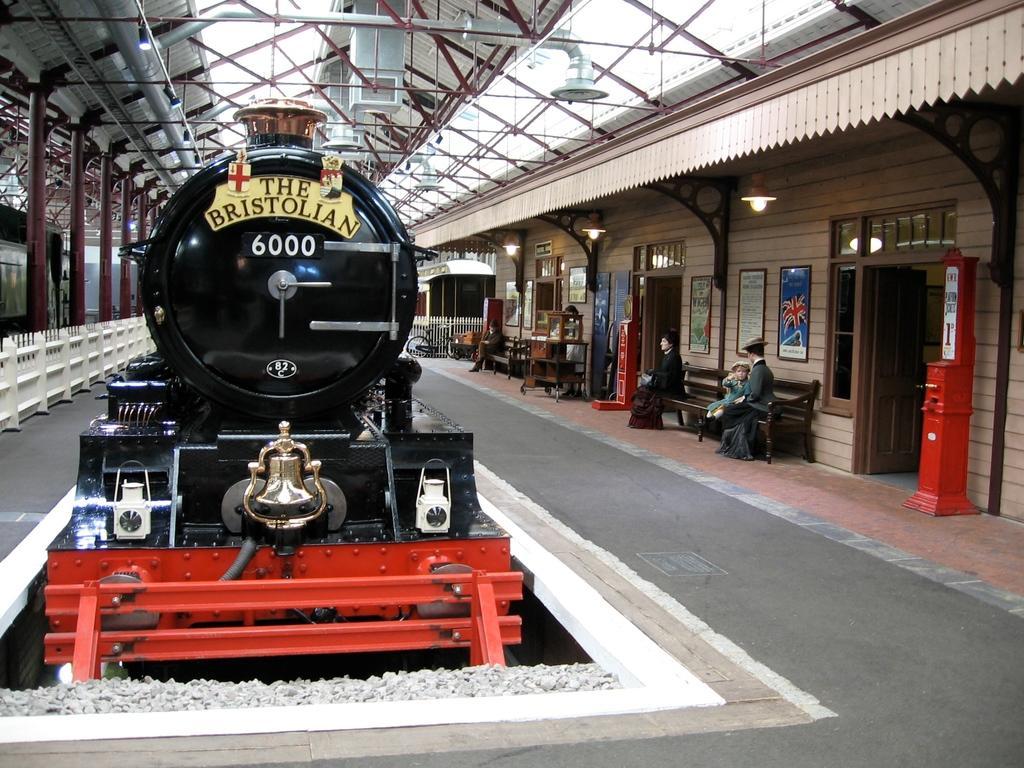How would you summarize this image in a sentence or two? On the left side, there is a black color train on a railway track. Beside this train, there is a fence and there are pillars. Above this train, there is a roof. On the right side, there are persons sitting on benches and there are photo frames attached to the wall of a building which is having lights attached to the roof. In the background, there is a bicycle and other objects. 